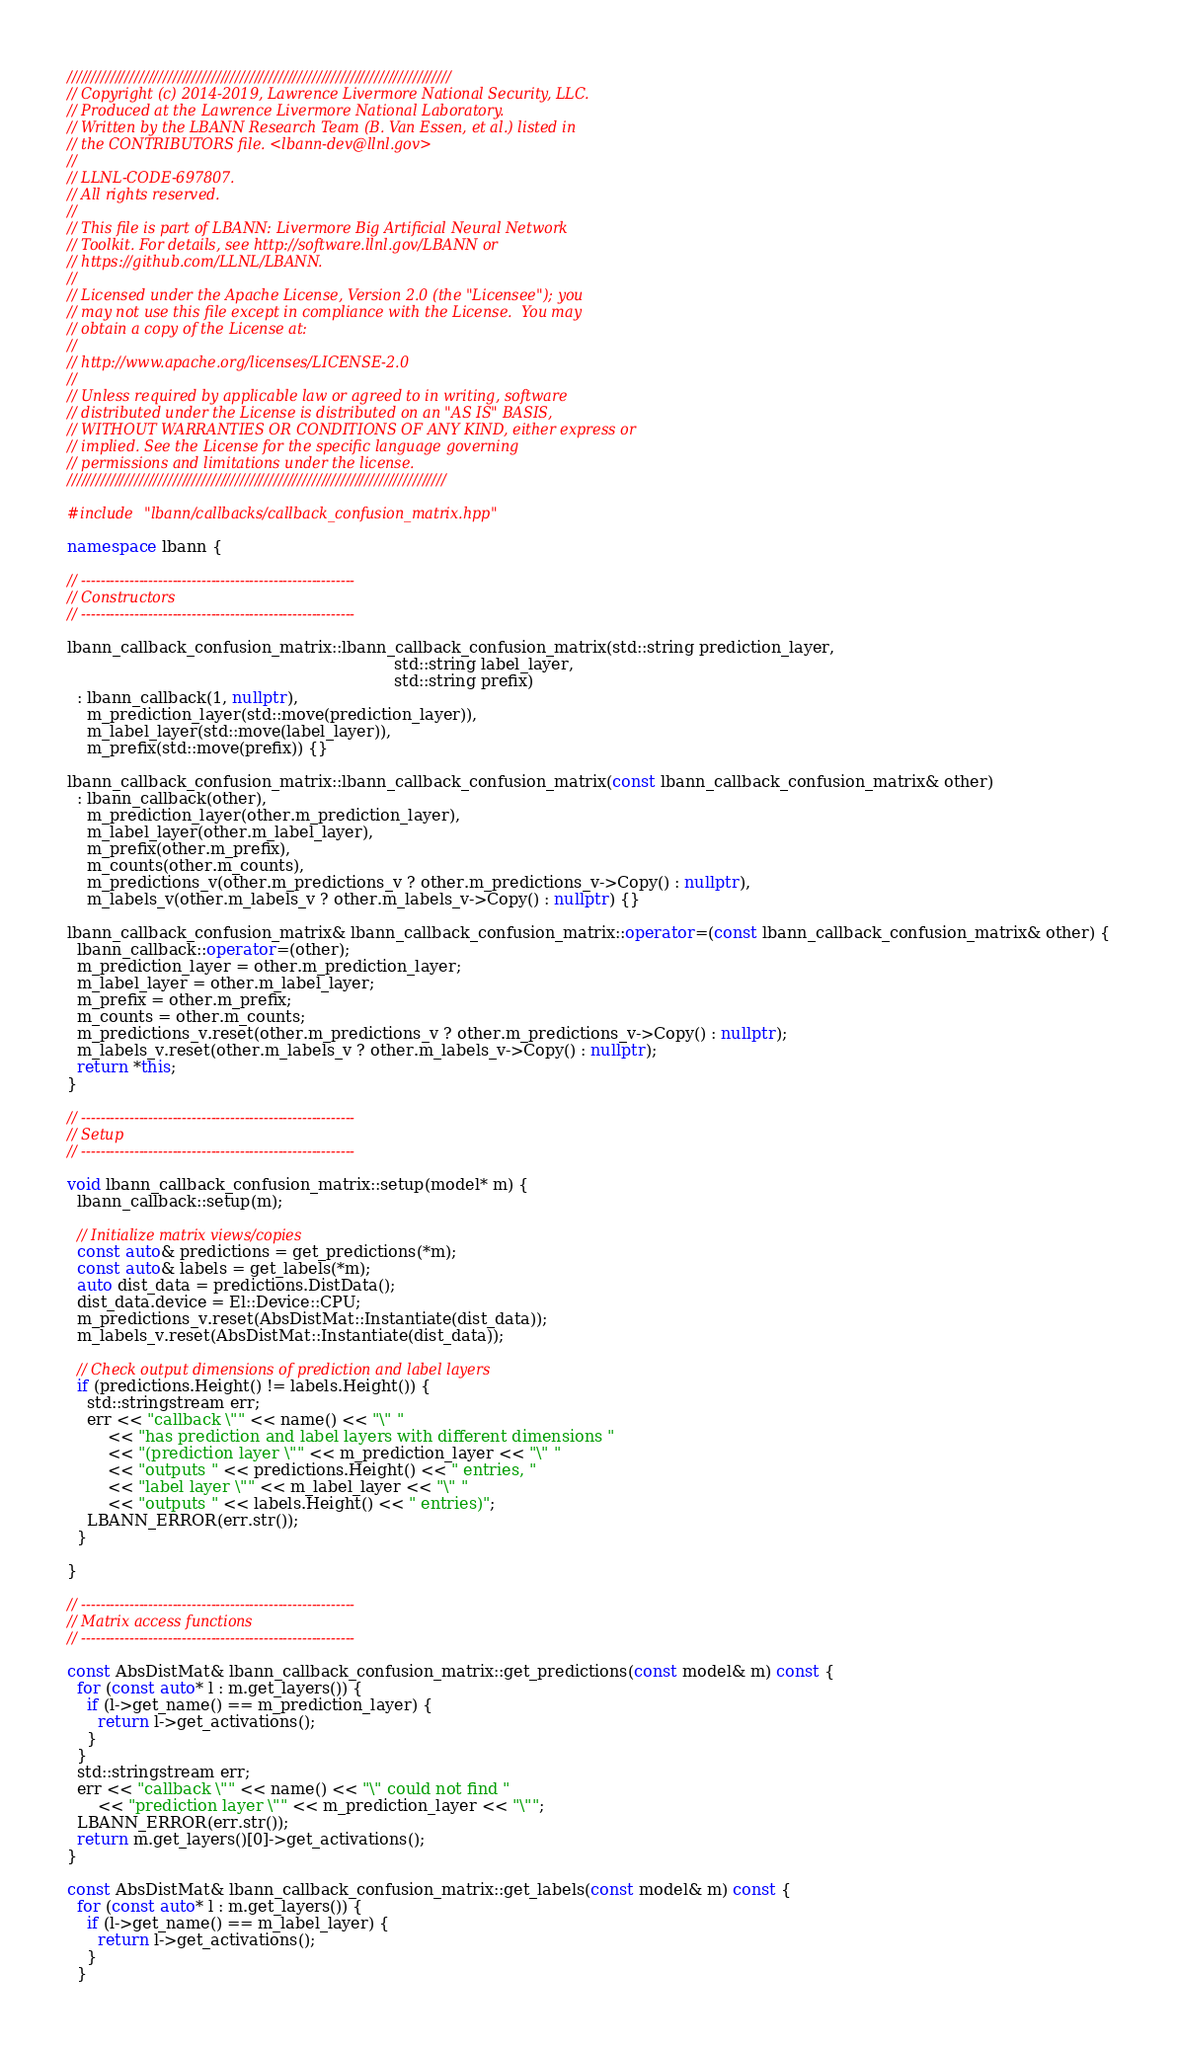Convert code to text. <code><loc_0><loc_0><loc_500><loc_500><_C++_>////////////////////////////////////////////////////////////////////////////////
// Copyright (c) 2014-2019, Lawrence Livermore National Security, LLC.
// Produced at the Lawrence Livermore National Laboratory.
// Written by the LBANN Research Team (B. Van Essen, et al.) listed in
// the CONTRIBUTORS file. <lbann-dev@llnl.gov>
//
// LLNL-CODE-697807.
// All rights reserved.
//
// This file is part of LBANN: Livermore Big Artificial Neural Network
// Toolkit. For details, see http://software.llnl.gov/LBANN or
// https://github.com/LLNL/LBANN.
//
// Licensed under the Apache License, Version 2.0 (the "Licensee"); you
// may not use this file except in compliance with the License.  You may
// obtain a copy of the License at:
//
// http://www.apache.org/licenses/LICENSE-2.0
//
// Unless required by applicable law or agreed to in writing, software
// distributed under the License is distributed on an "AS IS" BASIS,
// WITHOUT WARRANTIES OR CONDITIONS OF ANY KIND, either express or
// implied. See the License for the specific language governing
// permissions and limitations under the license.
///////////////////////////////////////////////////////////////////////////////

#include "lbann/callbacks/callback_confusion_matrix.hpp"

namespace lbann {

// ---------------------------------------------------------
// Constructors
// ---------------------------------------------------------

lbann_callback_confusion_matrix::lbann_callback_confusion_matrix(std::string prediction_layer,
                                                                 std::string label_layer,
                                                                 std::string prefix)
  : lbann_callback(1, nullptr),
    m_prediction_layer(std::move(prediction_layer)),
    m_label_layer(std::move(label_layer)),
    m_prefix(std::move(prefix)) {}

lbann_callback_confusion_matrix::lbann_callback_confusion_matrix(const lbann_callback_confusion_matrix& other)
  : lbann_callback(other),
    m_prediction_layer(other.m_prediction_layer),
    m_label_layer(other.m_label_layer),
    m_prefix(other.m_prefix),
    m_counts(other.m_counts),
    m_predictions_v(other.m_predictions_v ? other.m_predictions_v->Copy() : nullptr),
    m_labels_v(other.m_labels_v ? other.m_labels_v->Copy() : nullptr) {}

lbann_callback_confusion_matrix& lbann_callback_confusion_matrix::operator=(const lbann_callback_confusion_matrix& other) {
  lbann_callback::operator=(other);
  m_prediction_layer = other.m_prediction_layer;
  m_label_layer = other.m_label_layer;
  m_prefix = other.m_prefix;
  m_counts = other.m_counts;
  m_predictions_v.reset(other.m_predictions_v ? other.m_predictions_v->Copy() : nullptr);
  m_labels_v.reset(other.m_labels_v ? other.m_labels_v->Copy() : nullptr);
  return *this;
}

// ---------------------------------------------------------
// Setup
// ---------------------------------------------------------

void lbann_callback_confusion_matrix::setup(model* m) {
  lbann_callback::setup(m);

  // Initialize matrix views/copies
  const auto& predictions = get_predictions(*m);
  const auto& labels = get_labels(*m);
  auto dist_data = predictions.DistData();
  dist_data.device = El::Device::CPU;
  m_predictions_v.reset(AbsDistMat::Instantiate(dist_data));
  m_labels_v.reset(AbsDistMat::Instantiate(dist_data));

  // Check output dimensions of prediction and label layers
  if (predictions.Height() != labels.Height()) {
    std::stringstream err;
    err << "callback \"" << name() << "\" "
        << "has prediction and label layers with different dimensions "
        << "(prediction layer \"" << m_prediction_layer << "\" "
        << "outputs " << predictions.Height() << " entries, "
        << "label layer \"" << m_label_layer << "\" "
        << "outputs " << labels.Height() << " entries)";
    LBANN_ERROR(err.str());
  }

}

// ---------------------------------------------------------
// Matrix access functions
// ---------------------------------------------------------

const AbsDistMat& lbann_callback_confusion_matrix::get_predictions(const model& m) const {
  for (const auto* l : m.get_layers()) {
    if (l->get_name() == m_prediction_layer) {
      return l->get_activations();
    }
  }
  std::stringstream err;
  err << "callback \"" << name() << "\" could not find "
      << "prediction layer \"" << m_prediction_layer << "\"";
  LBANN_ERROR(err.str());
  return m.get_layers()[0]->get_activations();
}

const AbsDistMat& lbann_callback_confusion_matrix::get_labels(const model& m) const {
  for (const auto* l : m.get_layers()) {
    if (l->get_name() == m_label_layer) {
      return l->get_activations();
    }
  }</code> 